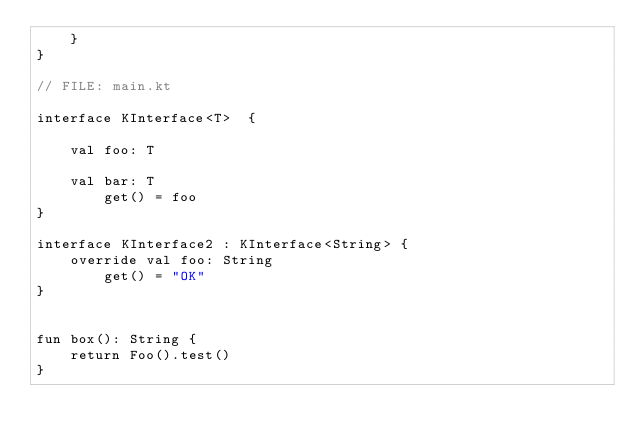<code> <loc_0><loc_0><loc_500><loc_500><_Kotlin_>    }
}

// FILE: main.kt

interface KInterface<T>  {

    val foo: T

    val bar: T
        get() = foo
}

interface KInterface2 : KInterface<String> {
    override val foo: String
        get() = "OK"
}


fun box(): String {
    return Foo().test()
}
</code> 